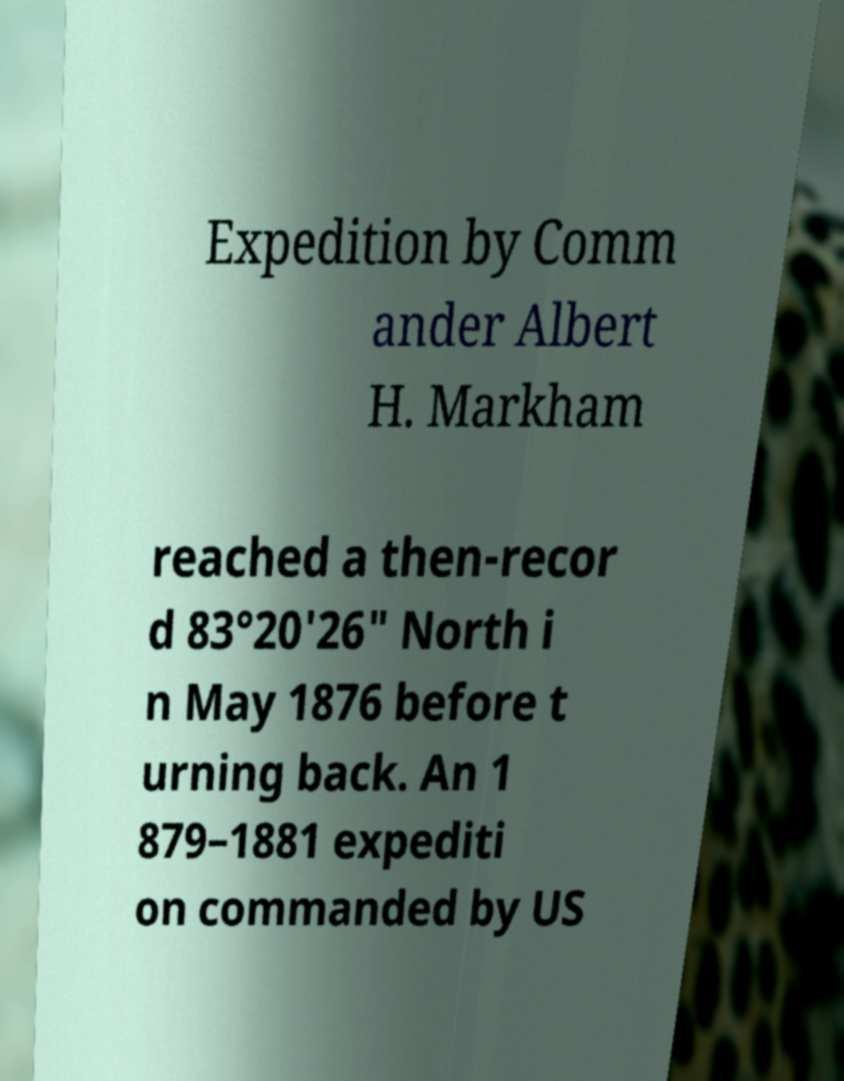Can you accurately transcribe the text from the provided image for me? Expedition by Comm ander Albert H. Markham reached a then-recor d 83°20'26" North i n May 1876 before t urning back. An 1 879–1881 expediti on commanded by US 